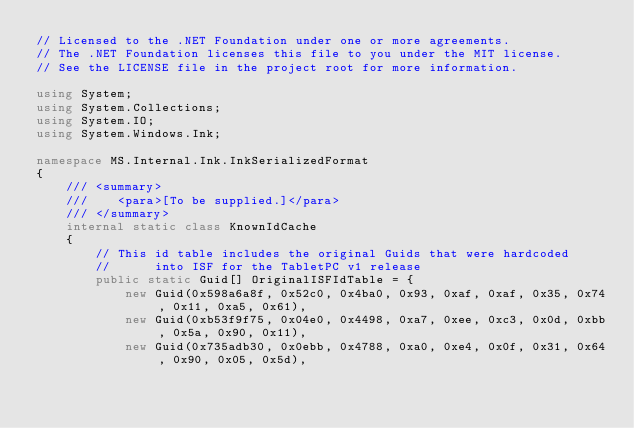Convert code to text. <code><loc_0><loc_0><loc_500><loc_500><_C#_>// Licensed to the .NET Foundation under one or more agreements.
// The .NET Foundation licenses this file to you under the MIT license.
// See the LICENSE file in the project root for more information.

using System;
using System.Collections;
using System.IO;
using System.Windows.Ink;

namespace MS.Internal.Ink.InkSerializedFormat
{
    /// <summary>
    ///    <para>[To be supplied.]</para>
    /// </summary>
    internal static class KnownIdCache
    {
        // This id table includes the original Guids that were hardcoded
        //      into ISF for the TabletPC v1 release
        public static Guid[] OriginalISFIdTable = {
            new Guid(0x598a6a8f, 0x52c0, 0x4ba0, 0x93, 0xaf, 0xaf, 0x35, 0x74, 0x11, 0xa5, 0x61),
            new Guid(0xb53f9f75, 0x04e0, 0x4498, 0xa7, 0xee, 0xc3, 0x0d, 0xbb, 0x5a, 0x90, 0x11),
            new Guid(0x735adb30, 0x0ebb, 0x4788, 0xa0, 0xe4, 0x0f, 0x31, 0x64, 0x90, 0x05, 0x5d), </code> 